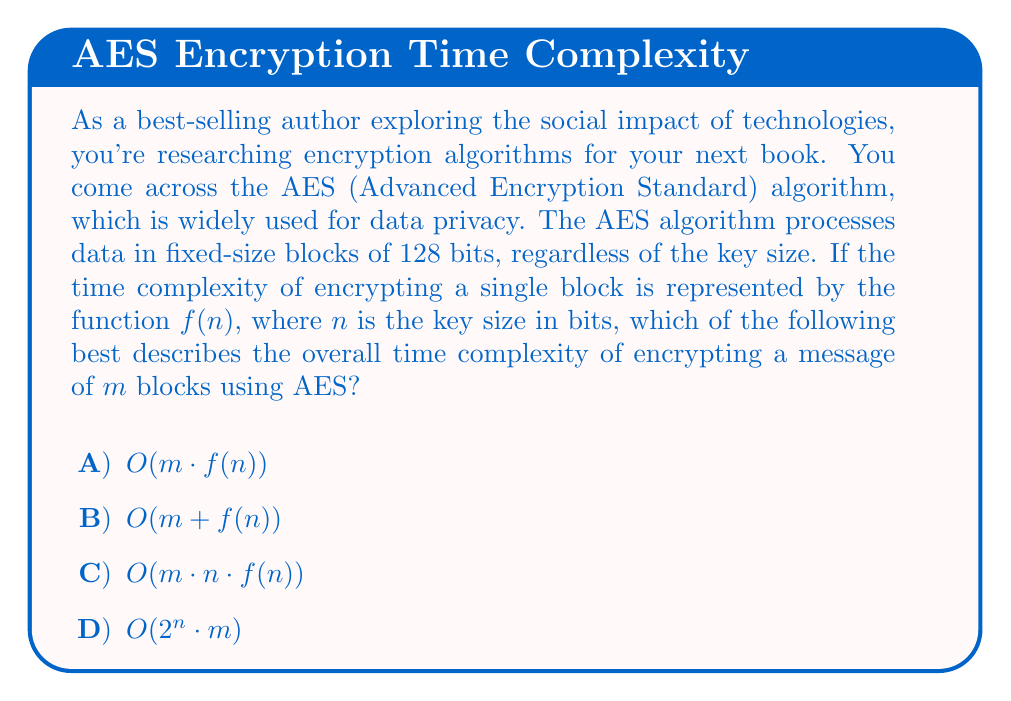Teach me how to tackle this problem. Let's analyze this step-by-step:

1) The AES algorithm processes data in fixed-size blocks of 128 bits. This means that for a message of $m$ blocks, the encryption process will need to be repeated $m$ times.

2) For each block, the encryption process depends on the key size $n$. Let's say this process has a time complexity of $f(n)$.

3) Since we need to perform this encryption $m$ times (once for each block), and each encryption takes $f(n)$ time, we multiply these factors:

   $$\text{Total time} = m \cdot f(n)$$

4) In Big O notation, this is expressed as $O(m \cdot f(n))$.

5) The other options can be ruled out:
   - $O(m + f(n))$ would imply that we only encrypt one block with the key-dependent complexity.
   - $O(m \cdot n \cdot f(n))$ incorrectly suggests that the key size $n$ is an additional multiplicative factor.
   - $O(2^n \cdot m)$ would represent an exponential time complexity with respect to the key size, which is not characteristic of AES.

6) It's important to note that while the time complexity increases linearly with the message size $m$, the relationship with the key size $n$ depends on the specific implementation of $f(n)$. In practice, AES is designed to be efficient, and the key scheduling (which depends on $n$) is typically done once and reused for all blocks.

This analysis helps understand the scalability of AES encryption with respect to message size and key size, which is crucial when considering its application in data privacy technologies.
Answer: $O(m \cdot f(n))$ 